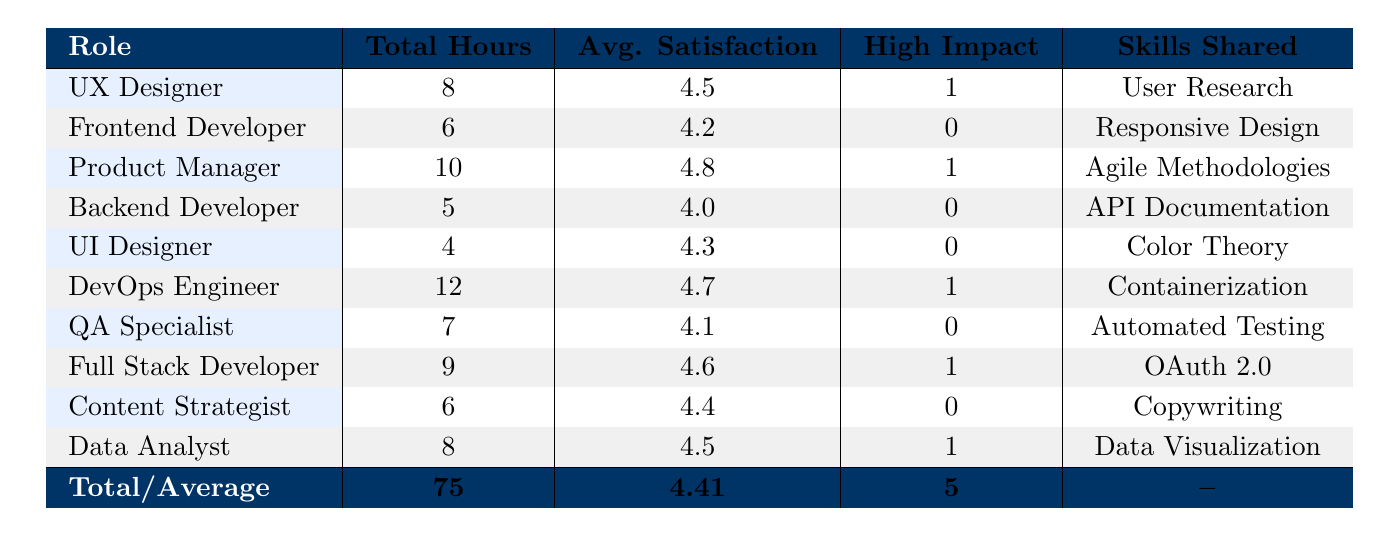What is the total number of hours spent on skill sharing by all team members? To find the total hours spent, we sum the values from the "Total Hours" column: 8 + 6 + 10 + 5 + 4 + 12 + 7 + 9 + 6 + 8 = 75.
Answer: 75 Which role has the highest average satisfaction score? From the "Avg. Satisfaction" column, we can see that the Product Manager has the highest satisfaction score of 4.8.
Answer: Product Manager Is there any role that had no high-impact skills shared? Looking at the "High Impact" column, we can see that the Frontend Developer, Backend Developer, UI Designer, QA Specialist, and Content Strategist all have a count of 0. Therefore, yes, there are roles without high-impact shared skills.
Answer: Yes What is the role with the lowest total hours spent on skill sharing? The UI Designer has the lowest total hours at 4, which is found in the "Total Hours" column.
Answer: UI Designer How many different skills were shared across different roles? The skills shared listed in the "Skills Shared" column are: User Research, Responsive Design, Agile Methodologies, API Documentation, Color Theory, Containerization, Automated Testing, OAuth 2.0, Copywriting, and Data Visualization. Counting these gives us 10 different skills.
Answer: 10 What is the average satisfaction score across all team members? To find the average satisfaction score, we sum the satisfaction scores: (4.5 + 4.2 + 4.8 + 4.0 + 4.3 + 4.7 + 4.1 + 4.6 + 4.4 + 4.5) = 44.1. Dividing this by the total number of entries (10) gives us 44.1 / 10 = 4.41.
Answer: 4.41 Which role shared a skill that had the highest impact on the project? The roles that shared skills with a "High" impact are UX Designer, Product Manager, DevOps Engineer, Full Stack Developer, and Data Analyst. Since there are multiple roles, we can see that they each contributed towards high-impact skills.
Answer: Multiple roles How many skills were shared by the role of the Full Stack Developer? The Full Stack Developer shared one skill, which is OAuth 2.0, identified in the "Skills Shared" column.
Answer: 1 What is the total count of team members who shared skills with a "High Impact" rating? We can see from the "High Impact" column that there are entries for the UX Designer, Product Manager, DevOps Engineer, Full Stack Developer, and Data Analyst, giving us a total count of 5 team members.
Answer: 5 Which role spent the most hours in skill sharing? By examining the "Total Hours" column, we identify that the DevOps Engineer spent the most hours at 12.
Answer: DevOps Engineer 